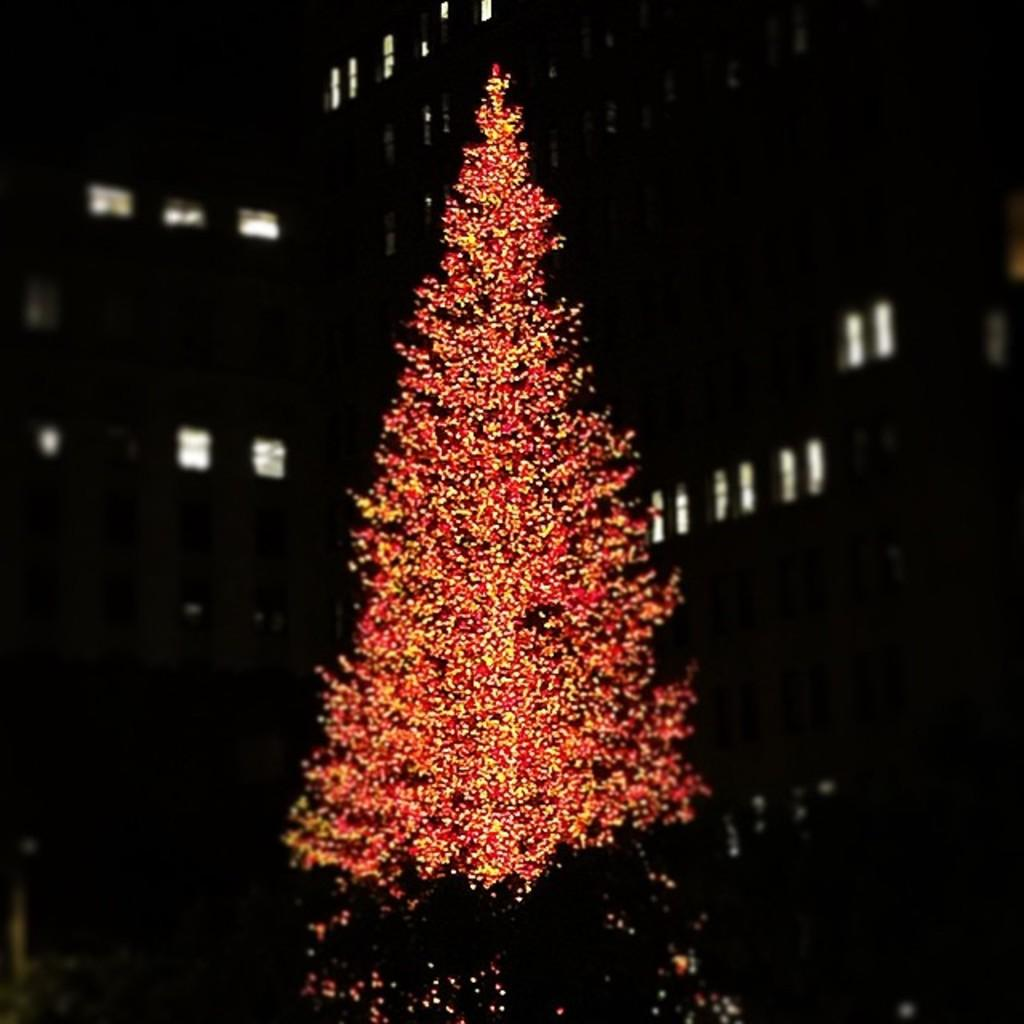What color of the tree in the image? There is a red color tree in the image. What can be seen in the background of the image? There are lights visible in the background of the image. How would you describe the overall lighting in the image? The image appears to be slightly dark in the background. What type of country is depicted in the image? There is no country depicted in the image; it features a red color tree and lights in the background. What produce is being harvested in the image? There is no produce being harvested in the image; it only shows a red color tree and lights in the background. 